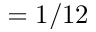<formula> <loc_0><loc_0><loc_500><loc_500>= 1 / 1 2</formula> 